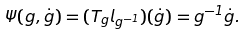Convert formula to latex. <formula><loc_0><loc_0><loc_500><loc_500>\Psi ( g , \dot { g } ) = ( T _ { g } l _ { g ^ { - 1 } } ) ( \dot { g } ) = g ^ { - 1 } \dot { g } .</formula> 